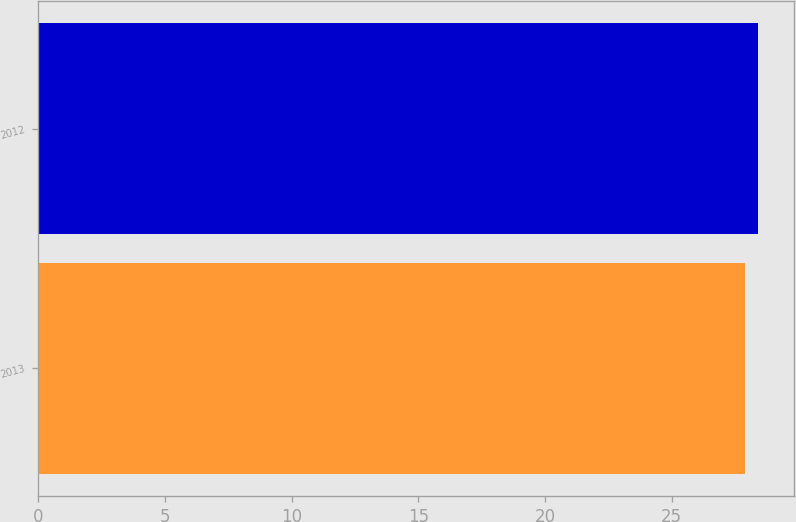Convert chart. <chart><loc_0><loc_0><loc_500><loc_500><bar_chart><fcel>2013<fcel>2012<nl><fcel>27.9<fcel>28.4<nl></chart> 